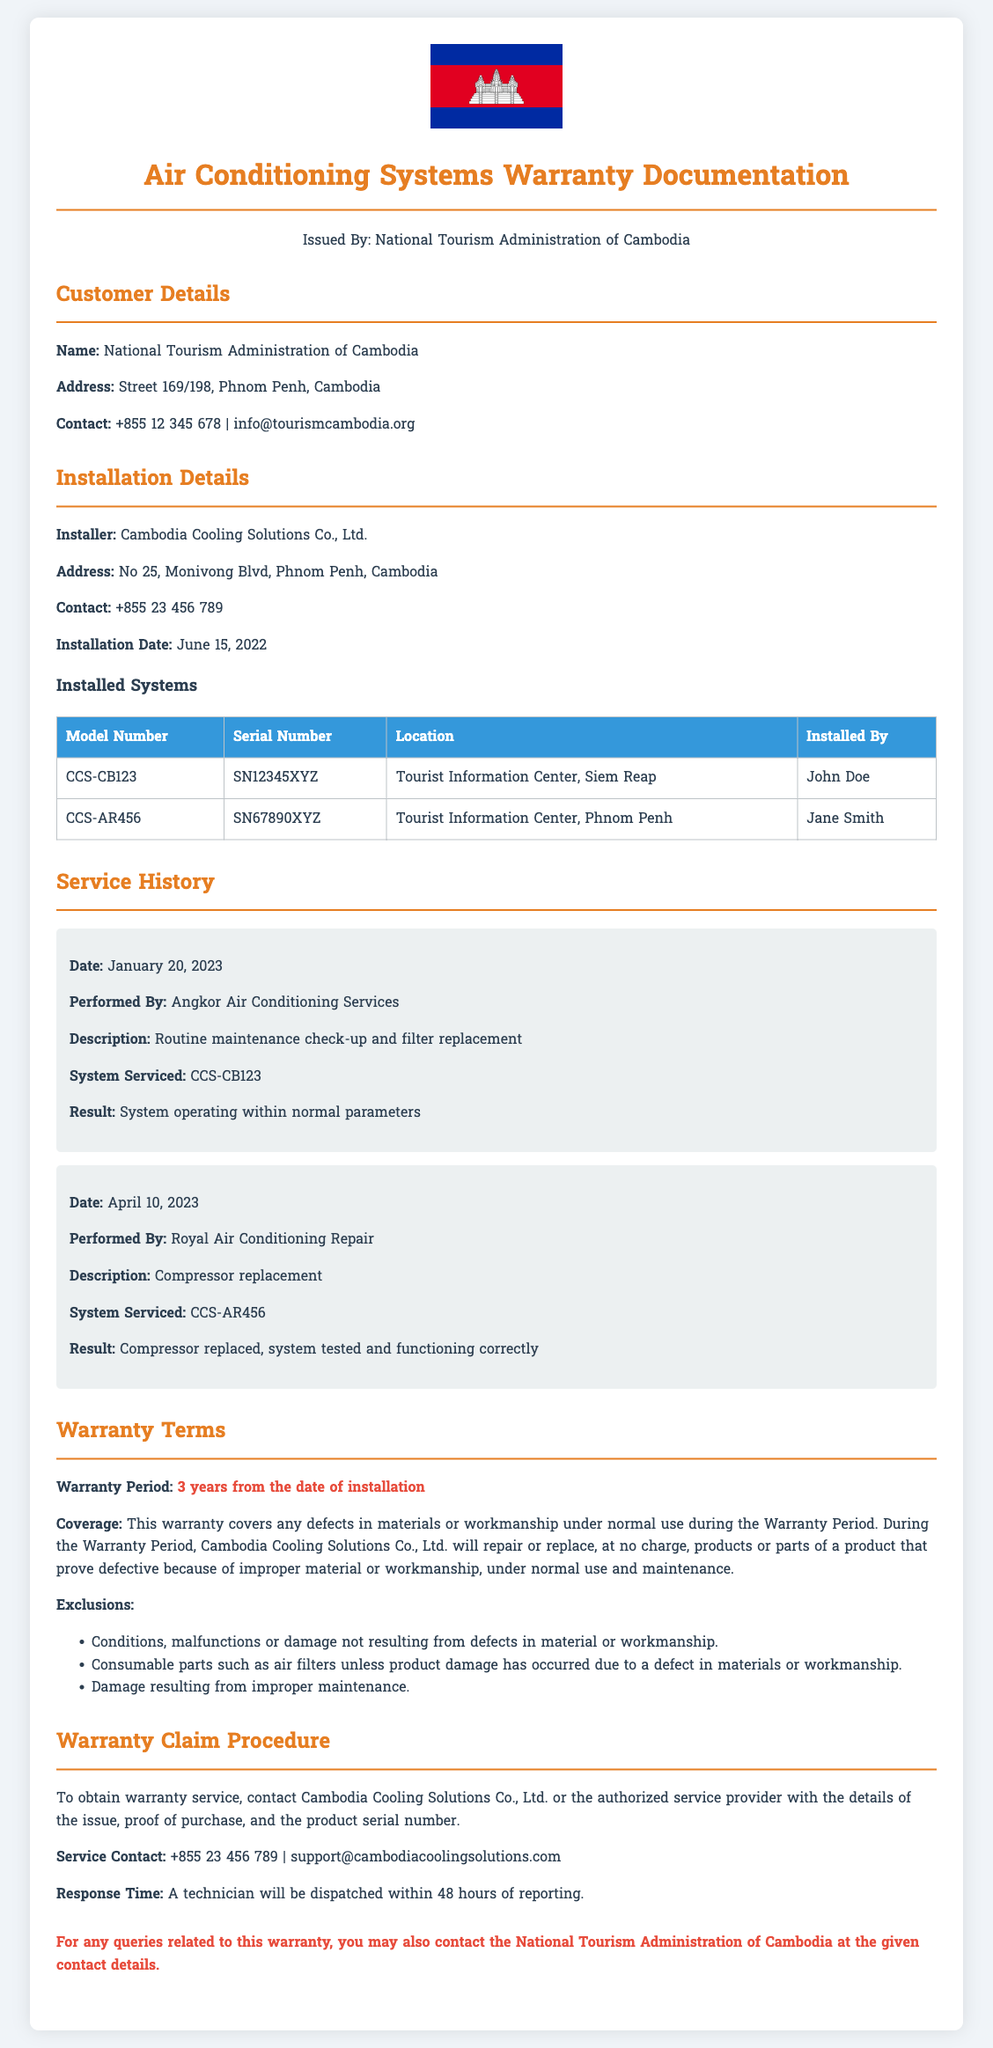what is the warranty period? The warranty period is specified in the document as lasting for 3 years from the date of installation.
Answer: 3 years who is the installer of the air conditioning systems? The installer mentioned in the document is Cambodia Cooling Solutions Co., Ltd.
Answer: Cambodia Cooling Solutions Co., Ltd what was the installation date? The installation date provided in the document is June 15, 2022.
Answer: June 15, 2022 how many systems were installed? The document lists two systems that were installed in different locations.
Answer: 2 systems what type of maintenance was performed on CCS-CB123 on January 20, 2023? The document describes the maintenance performed as a routine maintenance check-up and filter replacement.
Answer: routine maintenance check-up and filter replacement what is excluded from the warranty coverage? The document outlines several exclusions including conditions not resulting from defects and consumable parts such as air filters.
Answer: Conditions not resulting from defects and consumable parts such as air filters how can one obtain warranty service? To obtain warranty service, a contact to Cambodia Cooling Solutions Co., Ltd. or the authorized service provider is required with details of the issue and proof of purchase.
Answer: Contact Cambodia Cooling Solutions Co., Ltd what should the customer provide for a warranty claim? The document states that customers must provide details of the issue, proof of purchase, and the product serial number for a warranty claim.
Answer: details of the issue, proof of purchase, and the product serial number who performed the compressor replacement on April 10, 2023? The document indicates that the compressor replacement was performed by Royal Air Conditioning Repair.
Answer: Royal Air Conditioning Repair 